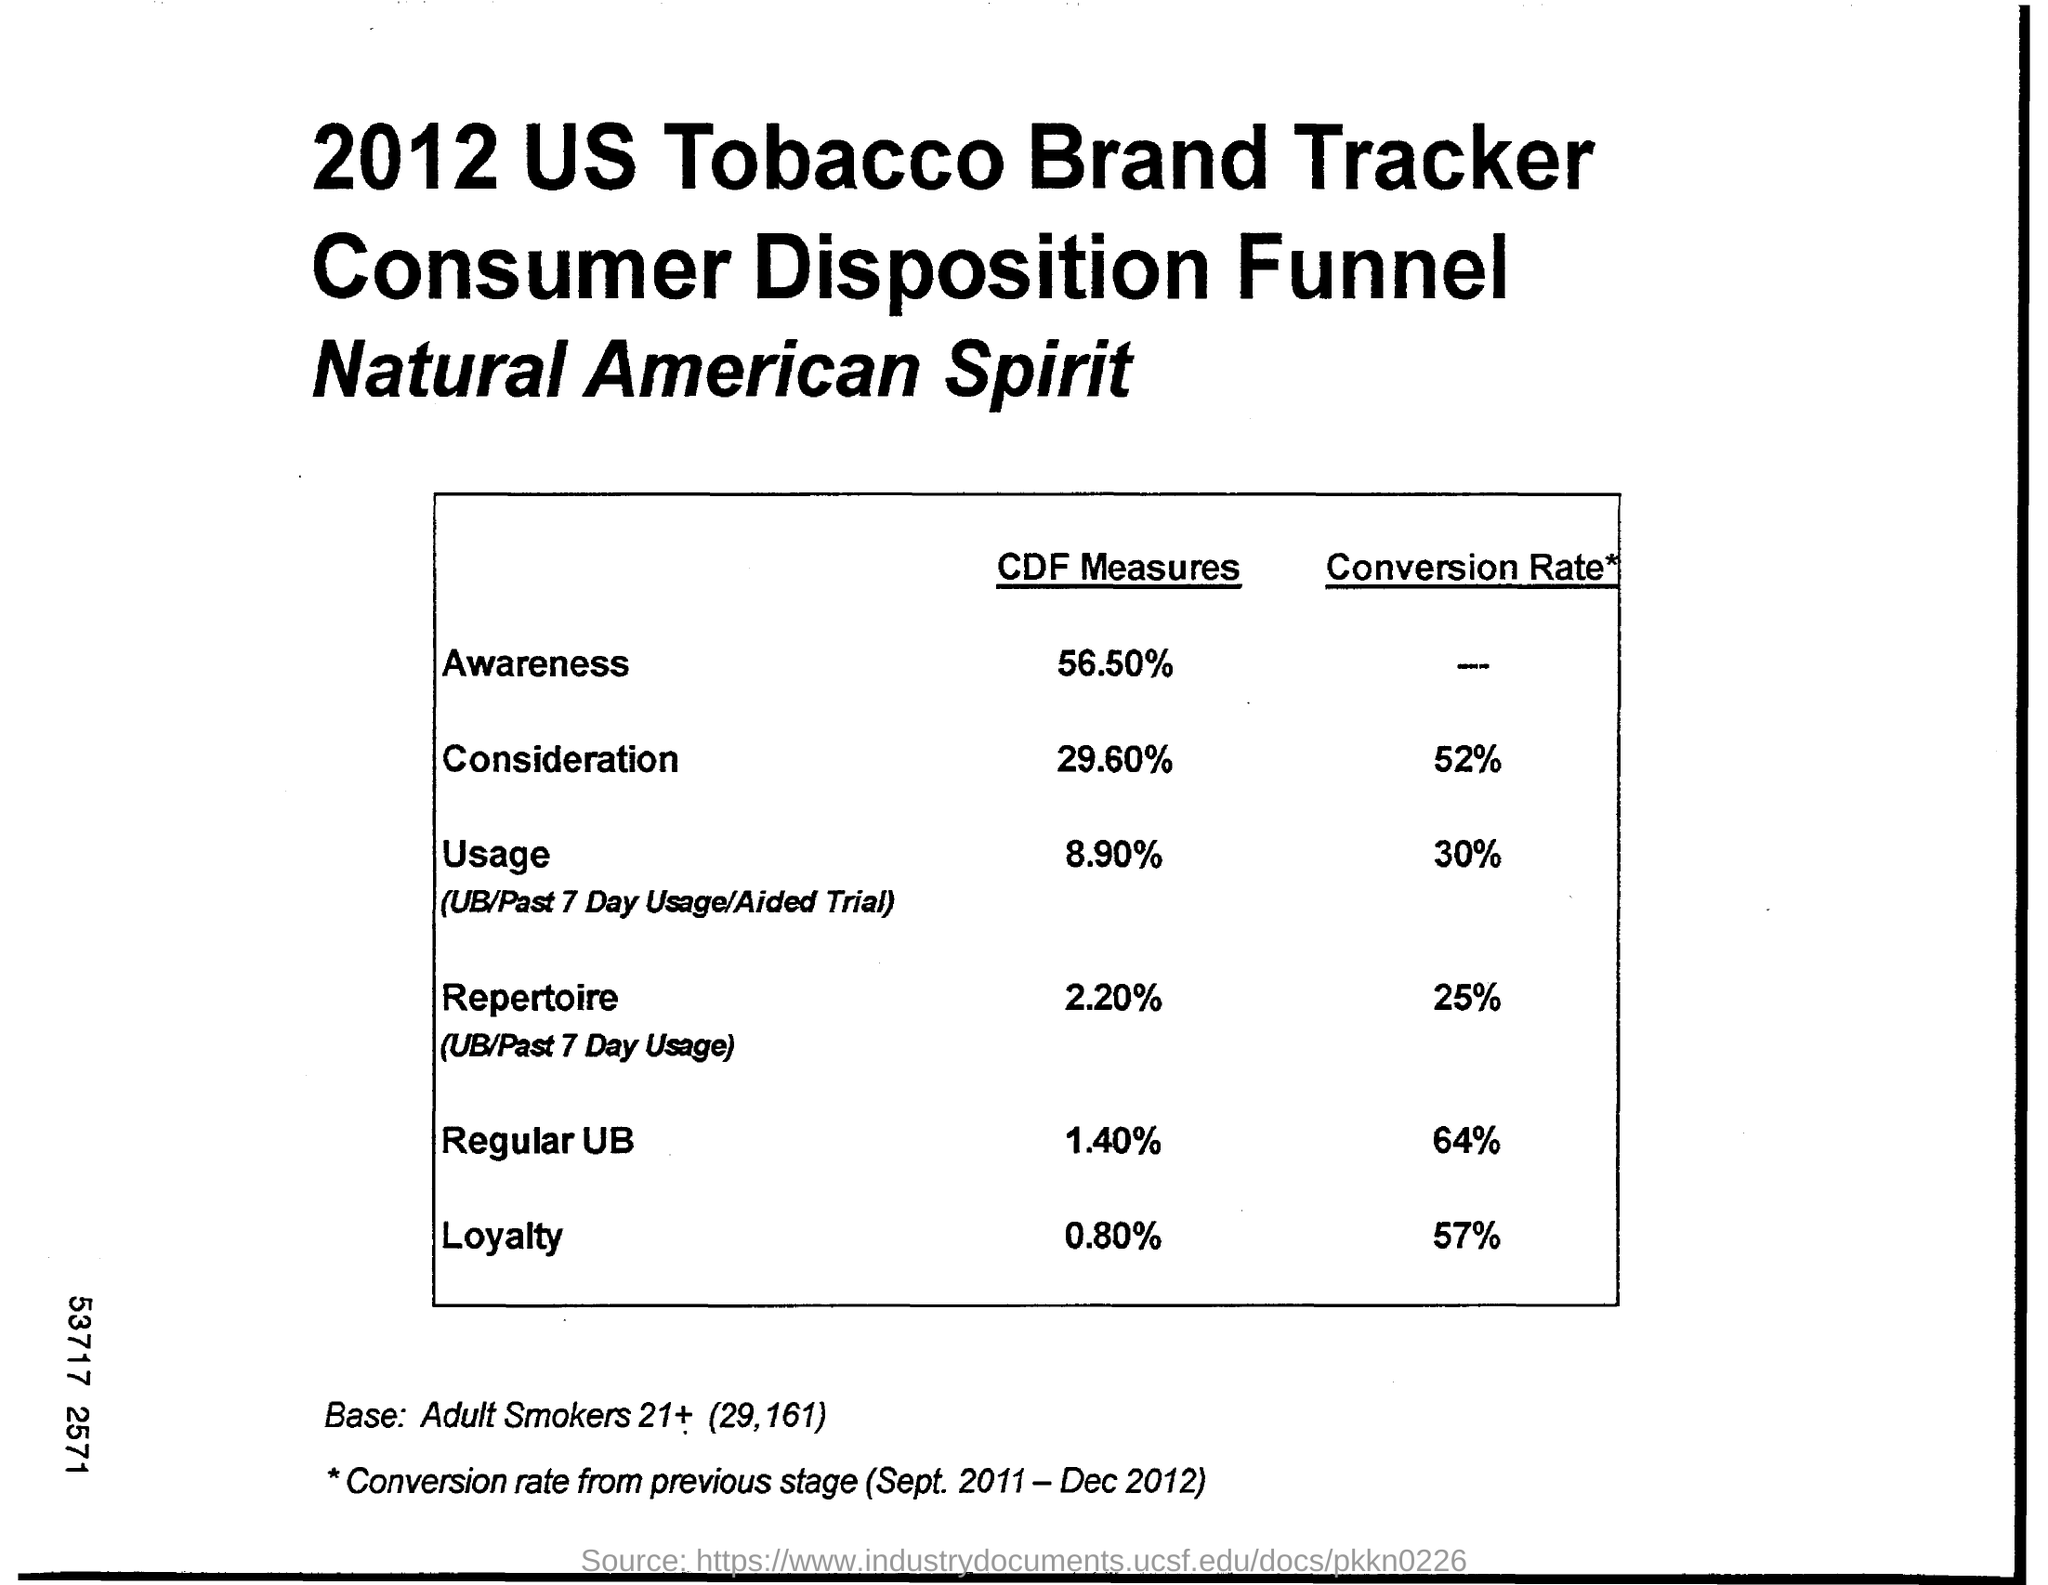Give some essential details in this illustration. The conversion rate for regular UB is 64%. The conversion rate for consideration is 52%. 